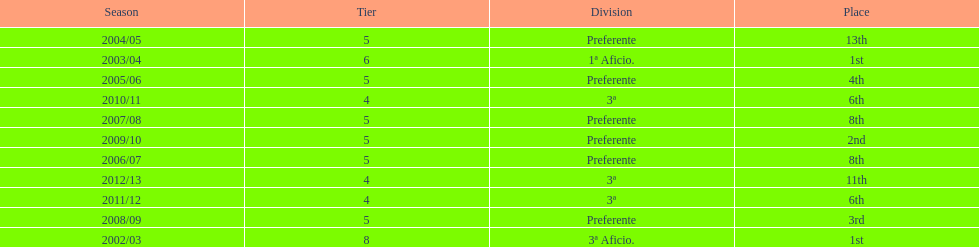How many times did internacional de madrid cf finish the season at the pinnacle of their division? 2. 